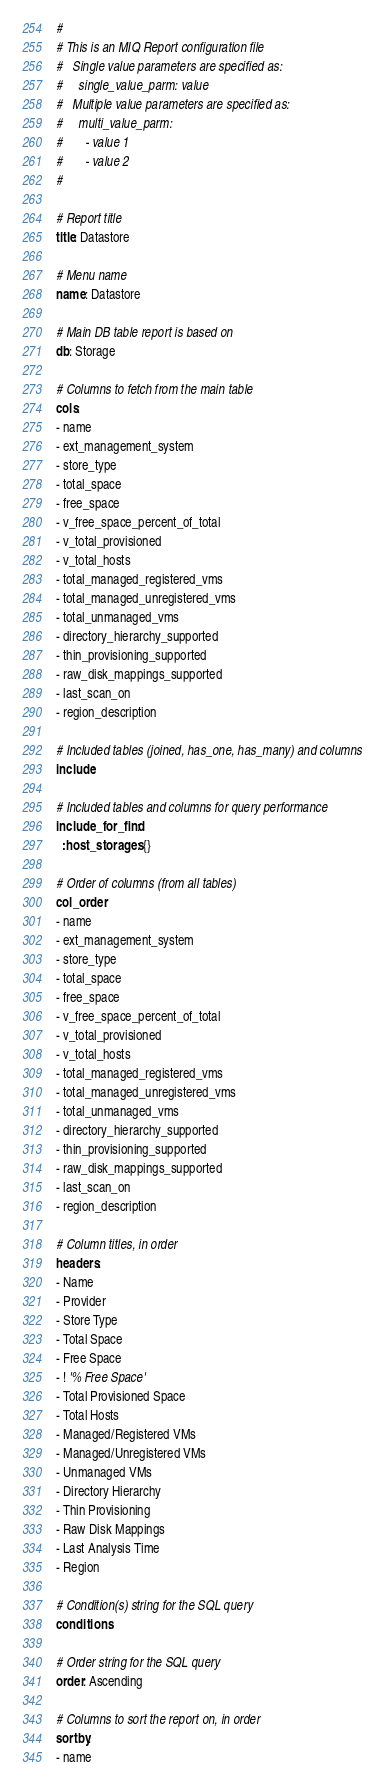Convert code to text. <code><loc_0><loc_0><loc_500><loc_500><_YAML_>#
# This is an MIQ Report configuration file
#   Single value parameters are specified as:
#     single_value_parm: value
#   Multiple value parameters are specified as:
#     multi_value_parm:
#       - value 1
#       - value 2
#

# Report title
title: Datastore

# Menu name
name: Datastore

# Main DB table report is based on
db: Storage

# Columns to fetch from the main table
cols:
- name
- ext_management_system
- store_type
- total_space
- free_space
- v_free_space_percent_of_total
- v_total_provisioned
- v_total_hosts
- total_managed_registered_vms
- total_managed_unregistered_vms
- total_unmanaged_vms
- directory_hierarchy_supported
- thin_provisioning_supported
- raw_disk_mappings_supported
- last_scan_on
- region_description

# Included tables (joined, has_one, has_many) and columns
include:

# Included tables and columns for query performance
include_for_find:
  :host_storages: {}

# Order of columns (from all tables)
col_order:
- name
- ext_management_system
- store_type
- total_space
- free_space
- v_free_space_percent_of_total
- v_total_provisioned
- v_total_hosts
- total_managed_registered_vms
- total_managed_unregistered_vms
- total_unmanaged_vms
- directory_hierarchy_supported
- thin_provisioning_supported
- raw_disk_mappings_supported
- last_scan_on
- region_description

# Column titles, in order
headers:
- Name
- Provider
- Store Type
- Total Space
- Free Space
- ! '% Free Space'
- Total Provisioned Space
- Total Hosts
- Managed/Registered VMs
- Managed/Unregistered VMs
- Unmanaged VMs
- Directory Hierarchy
- Thin Provisioning
- Raw Disk Mappings
- Last Analysis Time
- Region

# Condition(s) string for the SQL query
conditions:

# Order string for the SQL query
order: Ascending

# Columns to sort the report on, in order
sortby:
- name
</code> 